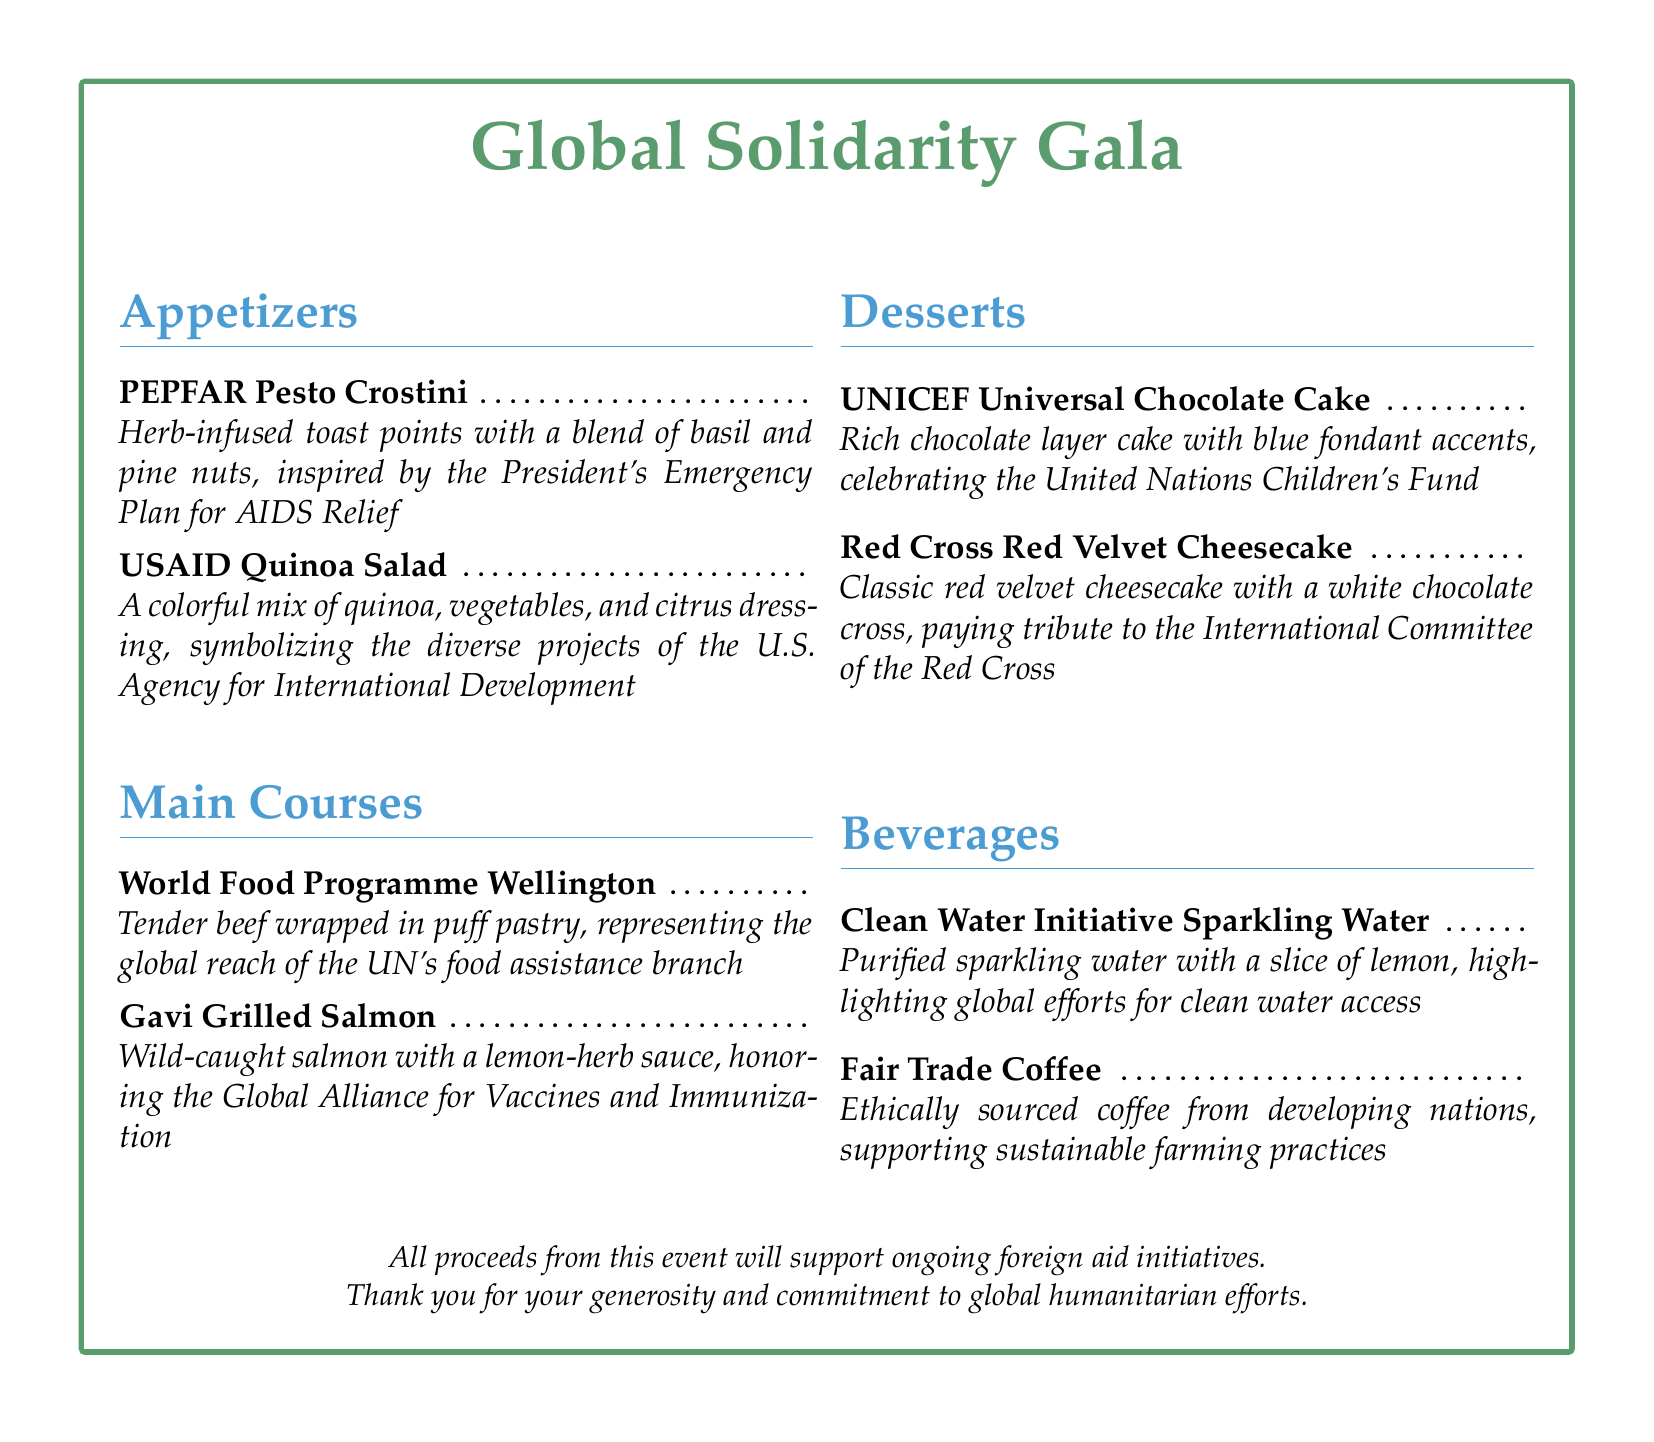What are the appetizers? The appetizers are listed under the Appetizers section in the menu, featuring two items specifically mentioned.
Answer: PEPFAR Pesto Crostini, USAID Quinoa Salad What does the Gavi Grilled Salmon honor? The Gavi Grilled Salmon is included in the main courses and honors a specific organization related to global health.
Answer: Global Alliance for Vaccines and Immunization How many dessert options are included in the menu? The menu lists sections, and the number of dessert items can be counted from the Desserts section.
Answer: 2 What is a beverage option highlighting global efforts for clean water access? The Beverages section contains a specific item that emphasizes clean water initiatives.
Answer: Clean Water Initiative Sparkling Water What is the color of the cake celebrating UNICEF? The dessert representing UNICEF is described with a specific color related to its theme and organization.
Answer: Chocolate What theme is the dinner menu focused on? The document's title indicates the overarching theme of the dinner event presented in the menu.
Answer: Global Solidarity What is the purpose of the funds raised by the event? The document states the intended use of the proceeds collected from the fundraiser dinner menu.
Answer: Support ongoing foreign aid initiatives 